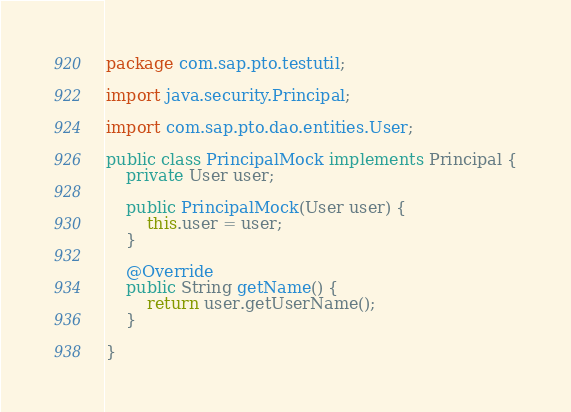Convert code to text. <code><loc_0><loc_0><loc_500><loc_500><_Java_>package com.sap.pto.testutil;

import java.security.Principal;

import com.sap.pto.dao.entities.User;

public class PrincipalMock implements Principal {
    private User user;

    public PrincipalMock(User user) {
        this.user = user;
    }

    @Override
    public String getName() {
        return user.getUserName();
    }

}
</code> 